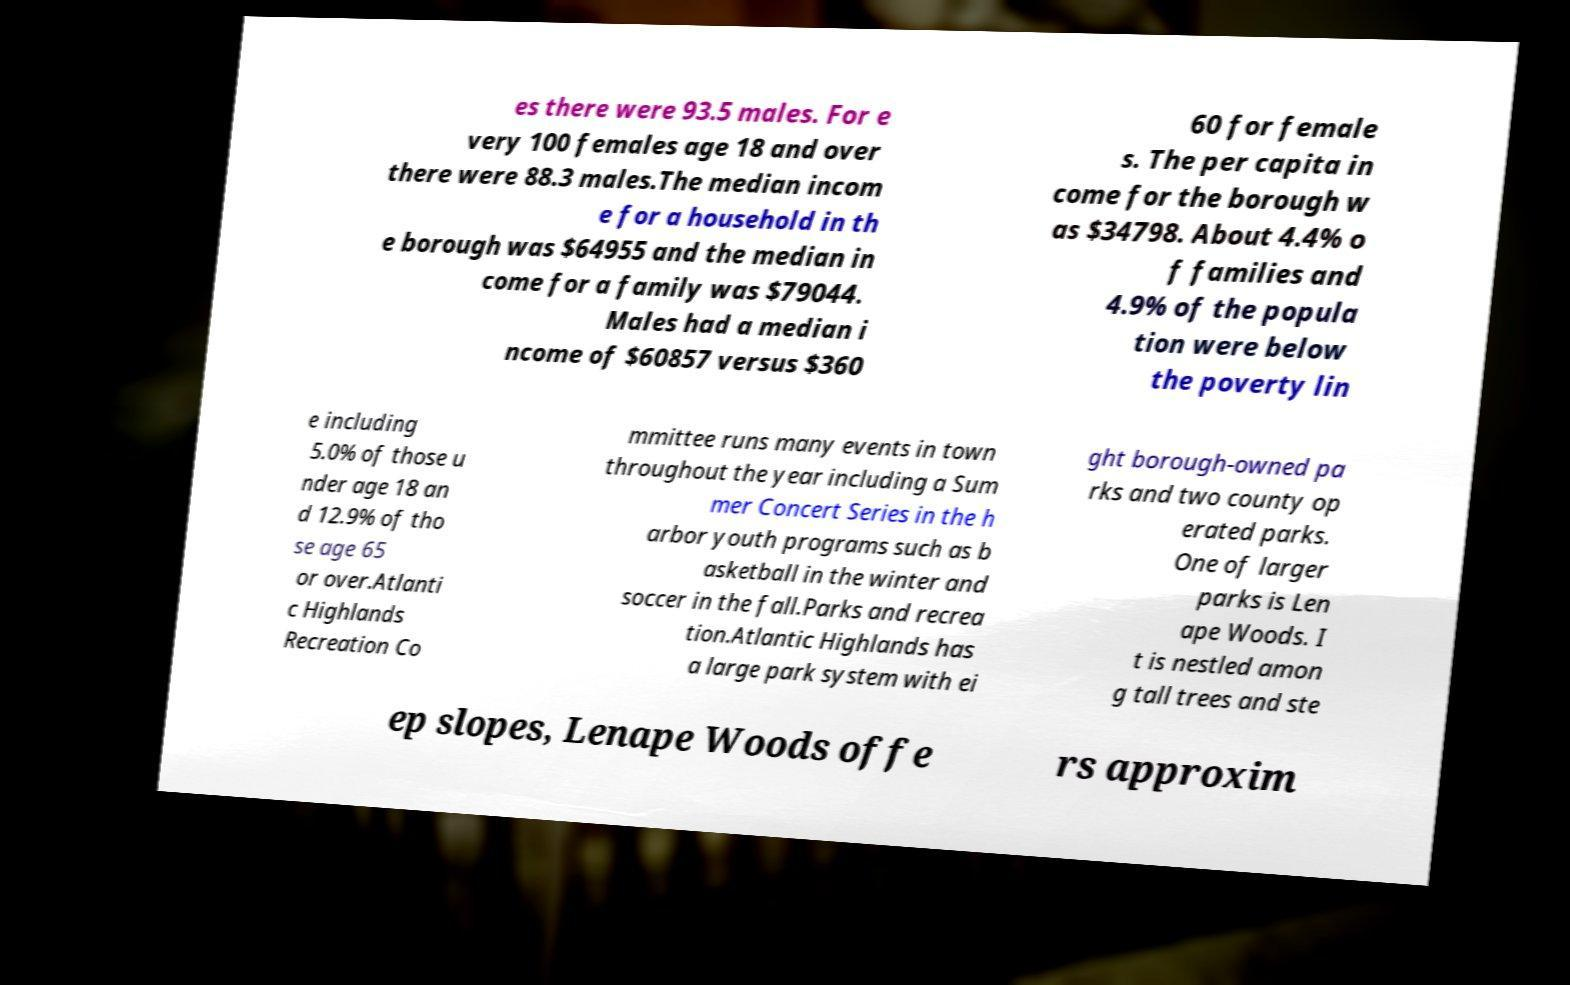There's text embedded in this image that I need extracted. Can you transcribe it verbatim? es there were 93.5 males. For e very 100 females age 18 and over there were 88.3 males.The median incom e for a household in th e borough was $64955 and the median in come for a family was $79044. Males had a median i ncome of $60857 versus $360 60 for female s. The per capita in come for the borough w as $34798. About 4.4% o f families and 4.9% of the popula tion were below the poverty lin e including 5.0% of those u nder age 18 an d 12.9% of tho se age 65 or over.Atlanti c Highlands Recreation Co mmittee runs many events in town throughout the year including a Sum mer Concert Series in the h arbor youth programs such as b asketball in the winter and soccer in the fall.Parks and recrea tion.Atlantic Highlands has a large park system with ei ght borough-owned pa rks and two county op erated parks. One of larger parks is Len ape Woods. I t is nestled amon g tall trees and ste ep slopes, Lenape Woods offe rs approxim 